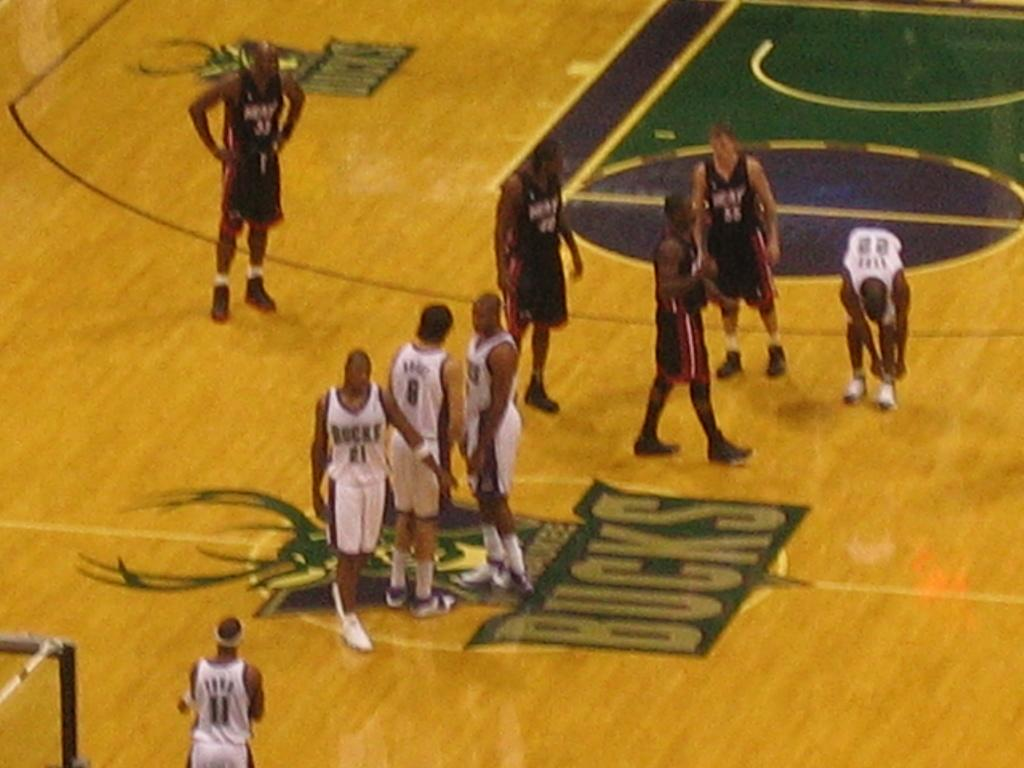What is happening in the image? There are people standing in the image. Where are the people standing? The people are standing on a floor. What is written on the floor? The word "Bucks" is written on the floor. Can you see any windows in the image? There is no mention of a window in the provided facts, so we cannot determine if there is a window in the image. 